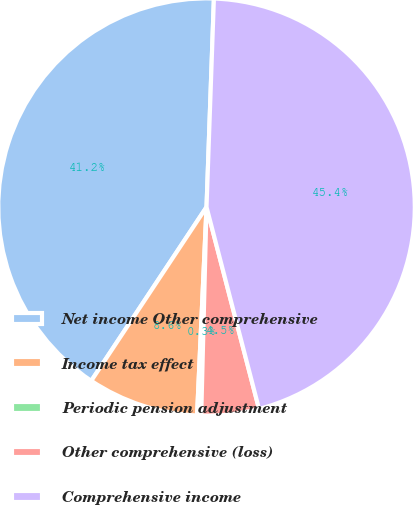<chart> <loc_0><loc_0><loc_500><loc_500><pie_chart><fcel>Net income Other comprehensive<fcel>Income tax effect<fcel>Periodic pension adjustment<fcel>Other comprehensive (loss)<fcel>Comprehensive income<nl><fcel>41.23%<fcel>8.61%<fcel>0.32%<fcel>4.46%<fcel>45.38%<nl></chart> 